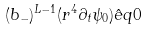Convert formula to latex. <formula><loc_0><loc_0><loc_500><loc_500>( b _ { - } ) ^ { L - 1 } ( r ^ { 4 } \partial _ { t } \psi _ { 0 } ) \hat { e } q 0</formula> 